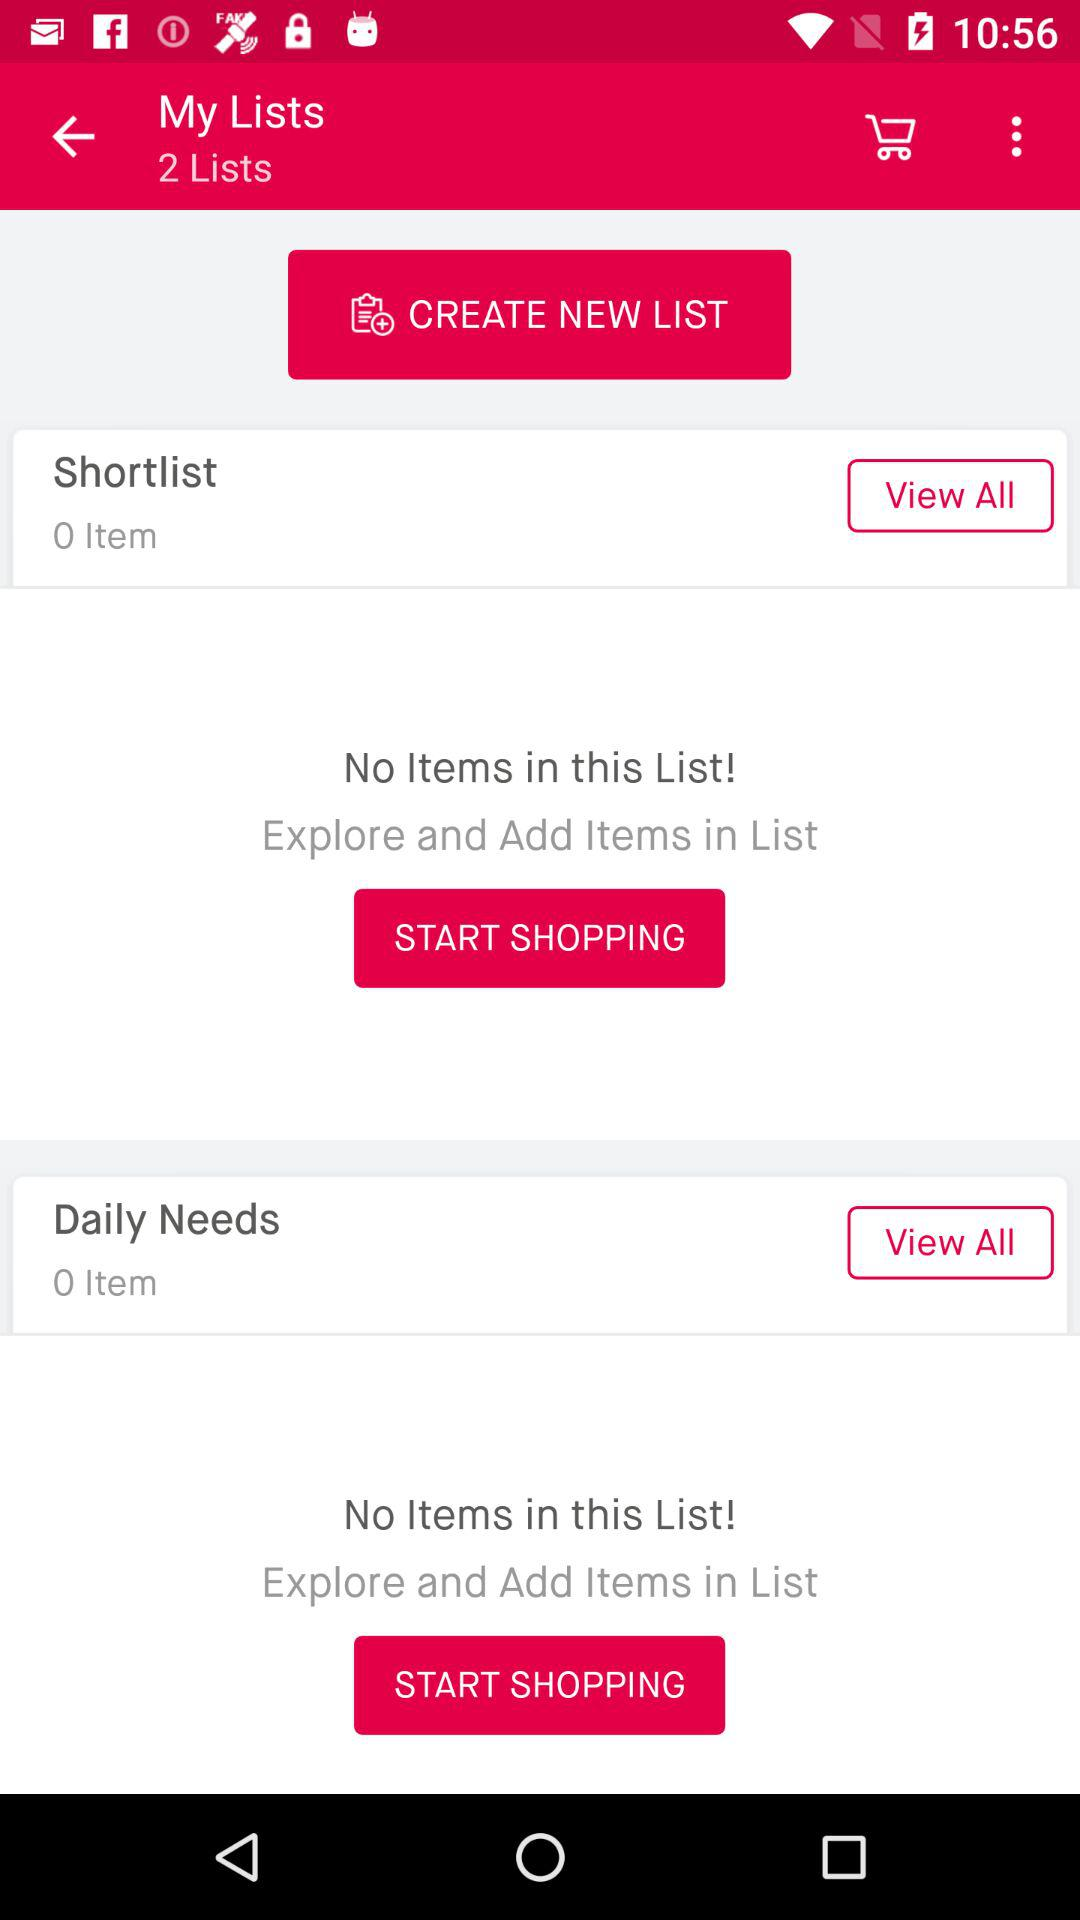How many items are there on the list of daily needs? There are 0 items on the list of daily needs. 